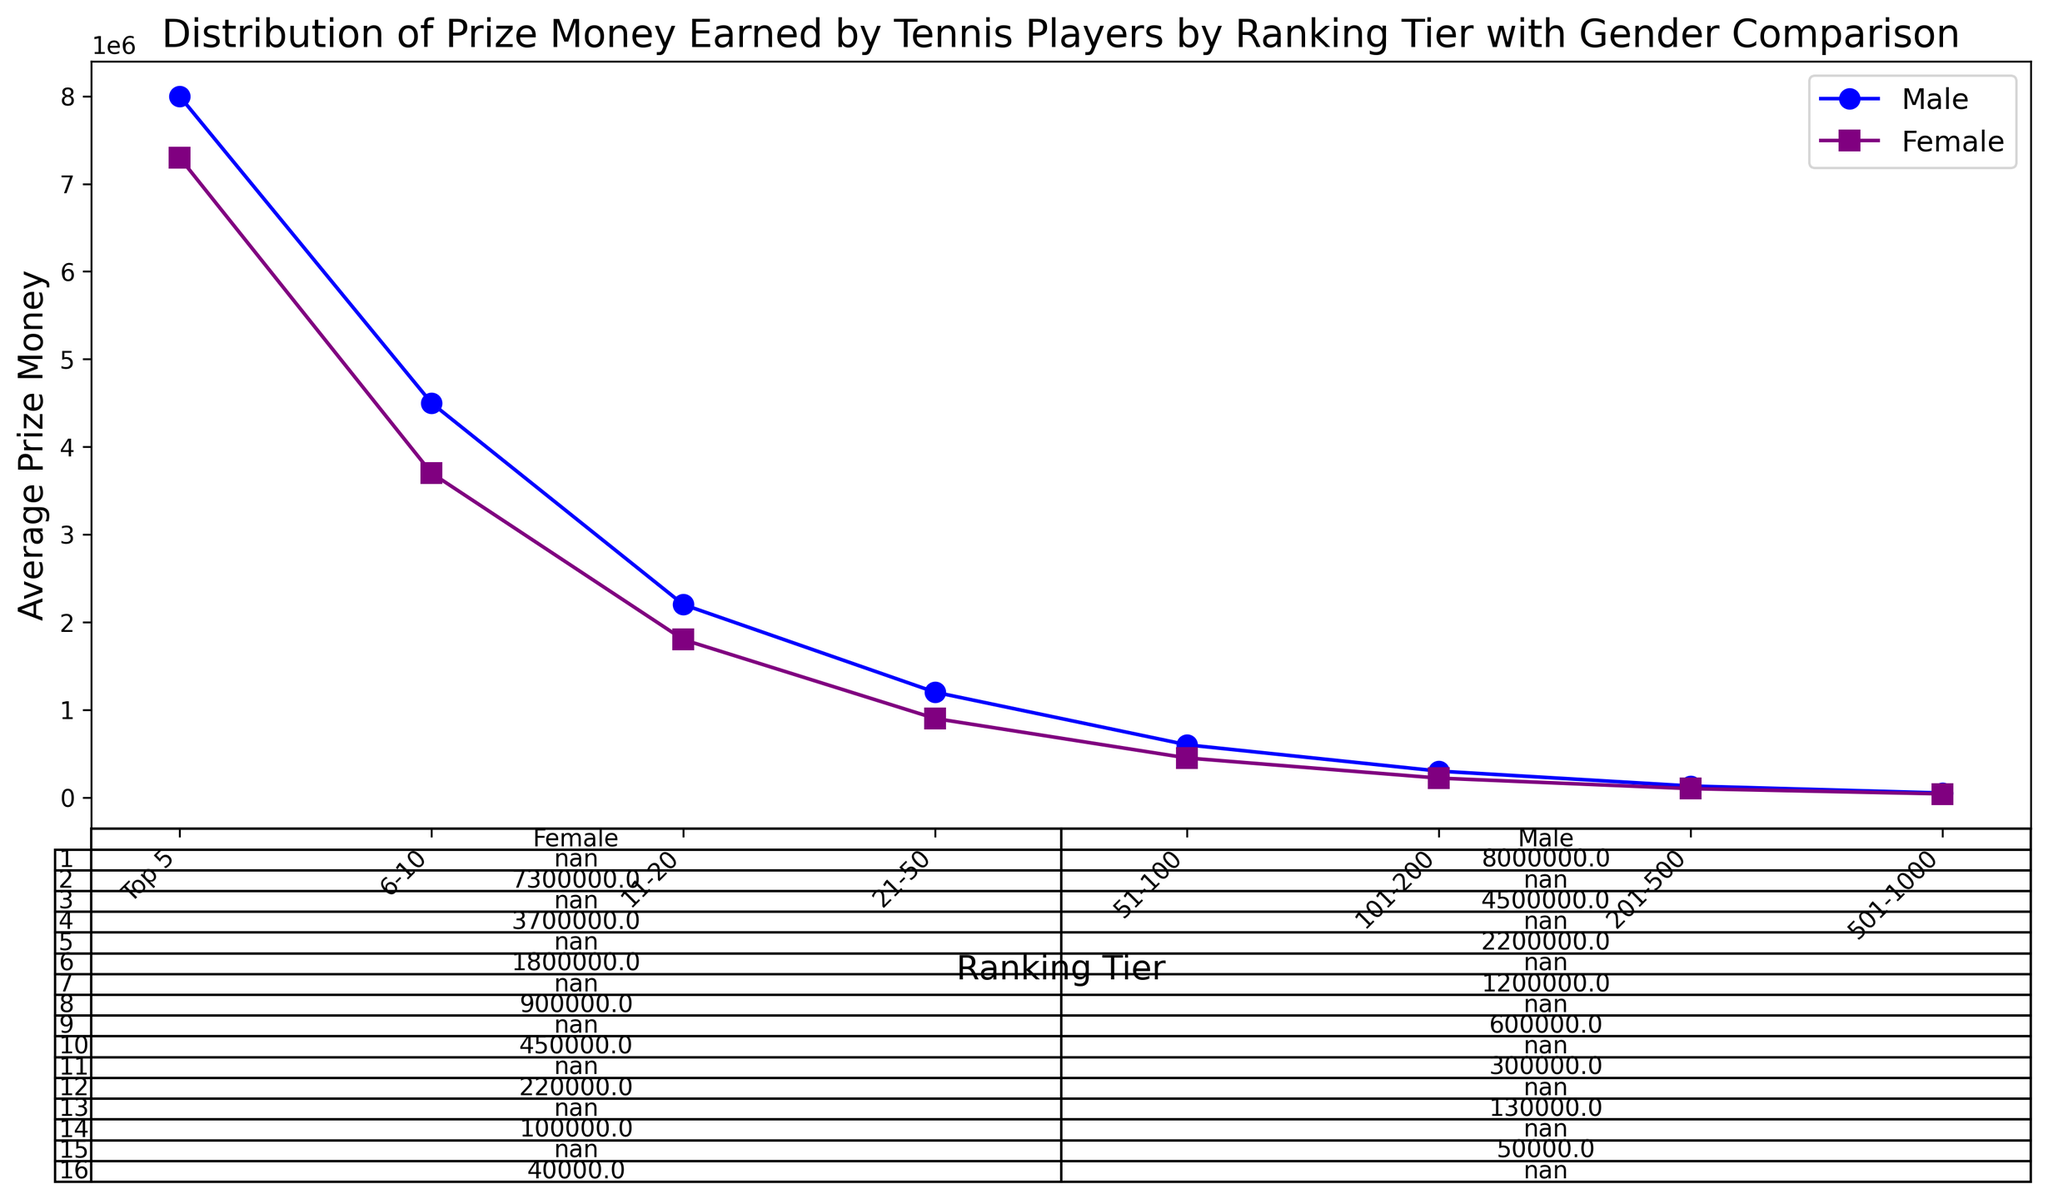Which gender has higher average prize money in the Top 5 tier? Look at the lines representing male and female players in the Top 5 tier, the y-values for males and females are 8,000,000 and 7,300,000 respectively.
Answer: Male Which ranking tier shows the smallest difference in average prize money between genders? Calculate the differences in prize money for each tier: Top 5 (800,000), 6-10 (800,000), 11-20 (400,000), 21-50 (300,000), 51-100 (150,000), 101-200 (80,000), 201-500 (30,000), 501-1000 (10,000). The 501-1000 tier shows the smallest difference.
Answer: 501-1000 What is the average prize money earned by male players in the 21-50 tier? Find the point corresponding to the 21-50 tier on the male line, which is directly labeled as an intersection point. The value is 1,200,000.
Answer: 1,200,000 What tier has the highest average prize money for female players? Locate the tier with the highest y-value on the female line, which is the Top 5 tier at 7,300,000.
Answer: Top 5 What is the difference in average prize money between male and female players in the 11-20 tier? Find the difference between the male and female average prize money for the 11-20 tier: 2,200,000 - 1,800,000 = 400,000.
Answer: 400,000 Which ranking tier experiences the steepest decline in average prize money for female players? Observe the slope of the line segments for female data. The most significant drop appears between the 6-10 tier (3,700,000) and the 11-20 tier (1,800,000), a drop of 1,900,000.
Answer: 6-10 to 11-20 Between which ranking tiers does the average prize money for male players fall below 1,000,000? Locate where the y-values for the male line cross below the 1,000,000 mark. This occurs between the 21-50 (1,200,000) and the 51-100 tiers (600,000).
Answer: 21-50 to 51-100 How does the participation of prize money distribution vary beyond ranking tier 100 for males and females? Examine the male and female lines after the 100th ranking tier. Prize money declines steadily, with males dropping from 300,000 to 50,000 and females dropping from 220,000 to 40,000.
Answer: Steady Decline 